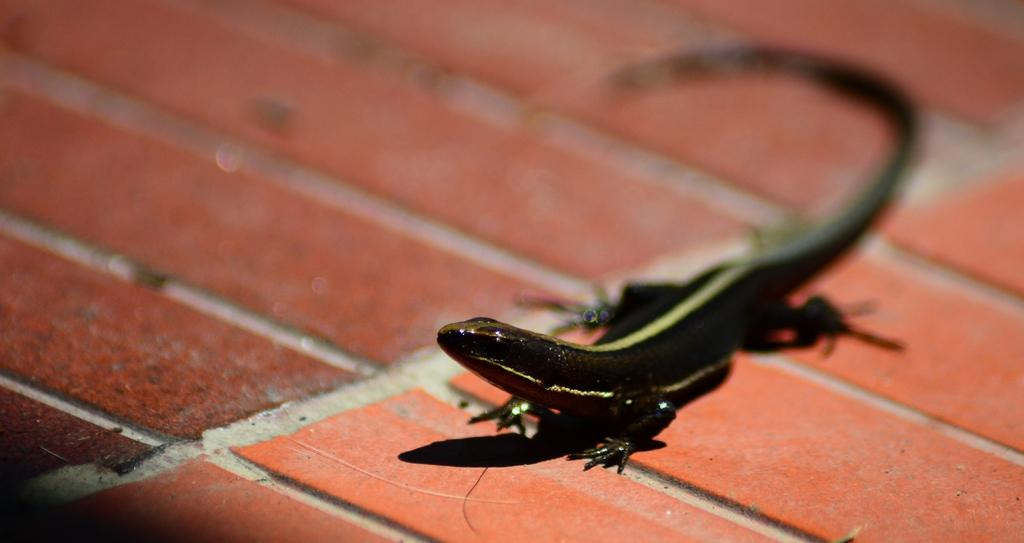What type of animal is present in the image? There is a skunk in the image. Where is the skunk located? The skunk is on the surface. What type of crate is the skunk sitting on in the image? There is no crate present in the image; the skunk is on the surface. What kind of stage is the skunk performing on in the image? There is no stage present in the image; the skunk is on the surface. 